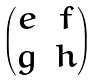<formula> <loc_0><loc_0><loc_500><loc_500>\begin{pmatrix} e & f \\ g & h \end{pmatrix}</formula> 